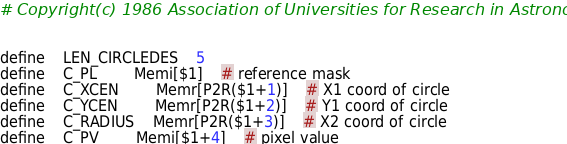Convert code to text. <code><loc_0><loc_0><loc_500><loc_500><_C_># Copyright(c) 1986 Association of Universities for Research in Astronomy Inc.


define	LEN_CIRCLEDES	5
define	C_PL		Memi[$1]	# reference mask
define	C_XCEN		Memr[P2R($1+1)]	# X1 coord of circle
define	C_YCEN		Memr[P2R($1+2)]	# Y1 coord of circle
define	C_RADIUS	Memr[P2R($1+3)]	# X2 coord of circle
define	C_PV		Memi[$1+4]	# pixel value

</code> 